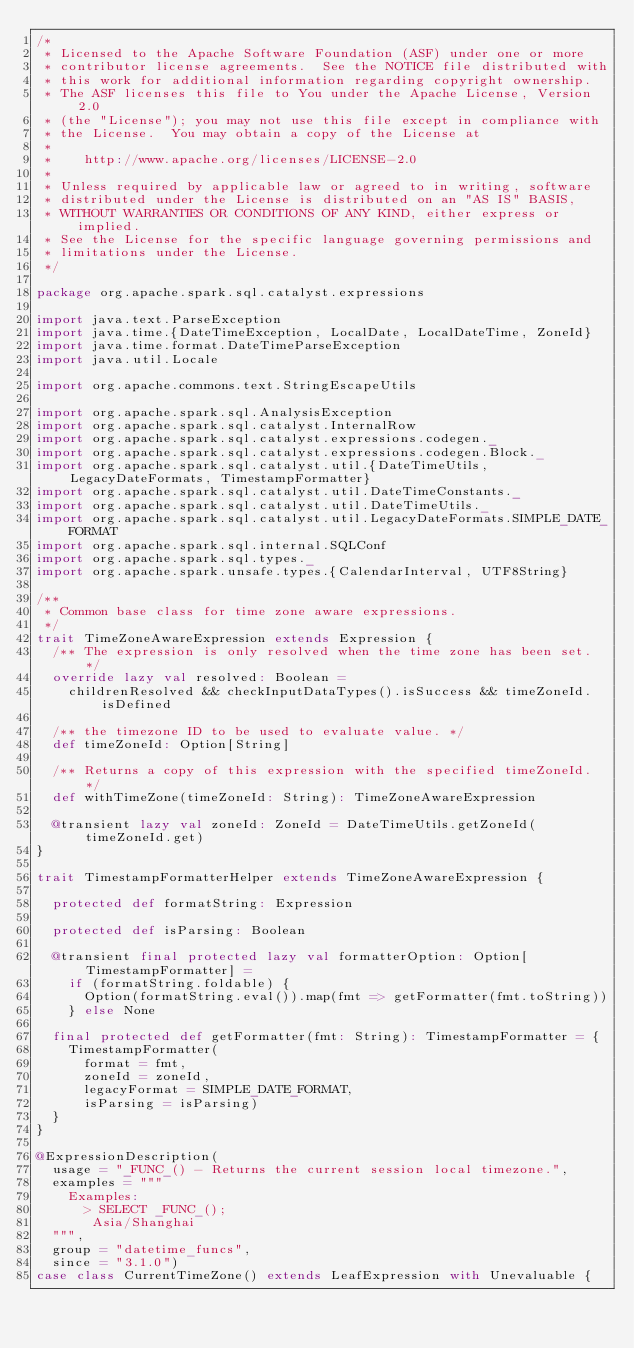<code> <loc_0><loc_0><loc_500><loc_500><_Scala_>/*
 * Licensed to the Apache Software Foundation (ASF) under one or more
 * contributor license agreements.  See the NOTICE file distributed with
 * this work for additional information regarding copyright ownership.
 * The ASF licenses this file to You under the Apache License, Version 2.0
 * (the "License"); you may not use this file except in compliance with
 * the License.  You may obtain a copy of the License at
 *
 *    http://www.apache.org/licenses/LICENSE-2.0
 *
 * Unless required by applicable law or agreed to in writing, software
 * distributed under the License is distributed on an "AS IS" BASIS,
 * WITHOUT WARRANTIES OR CONDITIONS OF ANY KIND, either express or implied.
 * See the License for the specific language governing permissions and
 * limitations under the License.
 */

package org.apache.spark.sql.catalyst.expressions

import java.text.ParseException
import java.time.{DateTimeException, LocalDate, LocalDateTime, ZoneId}
import java.time.format.DateTimeParseException
import java.util.Locale

import org.apache.commons.text.StringEscapeUtils

import org.apache.spark.sql.AnalysisException
import org.apache.spark.sql.catalyst.InternalRow
import org.apache.spark.sql.catalyst.expressions.codegen._
import org.apache.spark.sql.catalyst.expressions.codegen.Block._
import org.apache.spark.sql.catalyst.util.{DateTimeUtils, LegacyDateFormats, TimestampFormatter}
import org.apache.spark.sql.catalyst.util.DateTimeConstants._
import org.apache.spark.sql.catalyst.util.DateTimeUtils._
import org.apache.spark.sql.catalyst.util.LegacyDateFormats.SIMPLE_DATE_FORMAT
import org.apache.spark.sql.internal.SQLConf
import org.apache.spark.sql.types._
import org.apache.spark.unsafe.types.{CalendarInterval, UTF8String}

/**
 * Common base class for time zone aware expressions.
 */
trait TimeZoneAwareExpression extends Expression {
  /** The expression is only resolved when the time zone has been set. */
  override lazy val resolved: Boolean =
    childrenResolved && checkInputDataTypes().isSuccess && timeZoneId.isDefined

  /** the timezone ID to be used to evaluate value. */
  def timeZoneId: Option[String]

  /** Returns a copy of this expression with the specified timeZoneId. */
  def withTimeZone(timeZoneId: String): TimeZoneAwareExpression

  @transient lazy val zoneId: ZoneId = DateTimeUtils.getZoneId(timeZoneId.get)
}

trait TimestampFormatterHelper extends TimeZoneAwareExpression {

  protected def formatString: Expression

  protected def isParsing: Boolean

  @transient final protected lazy val formatterOption: Option[TimestampFormatter] =
    if (formatString.foldable) {
      Option(formatString.eval()).map(fmt => getFormatter(fmt.toString))
    } else None

  final protected def getFormatter(fmt: String): TimestampFormatter = {
    TimestampFormatter(
      format = fmt,
      zoneId = zoneId,
      legacyFormat = SIMPLE_DATE_FORMAT,
      isParsing = isParsing)
  }
}

@ExpressionDescription(
  usage = "_FUNC_() - Returns the current session local timezone.",
  examples = """
    Examples:
      > SELECT _FUNC_();
       Asia/Shanghai
  """,
  group = "datetime_funcs",
  since = "3.1.0")
case class CurrentTimeZone() extends LeafExpression with Unevaluable {</code> 